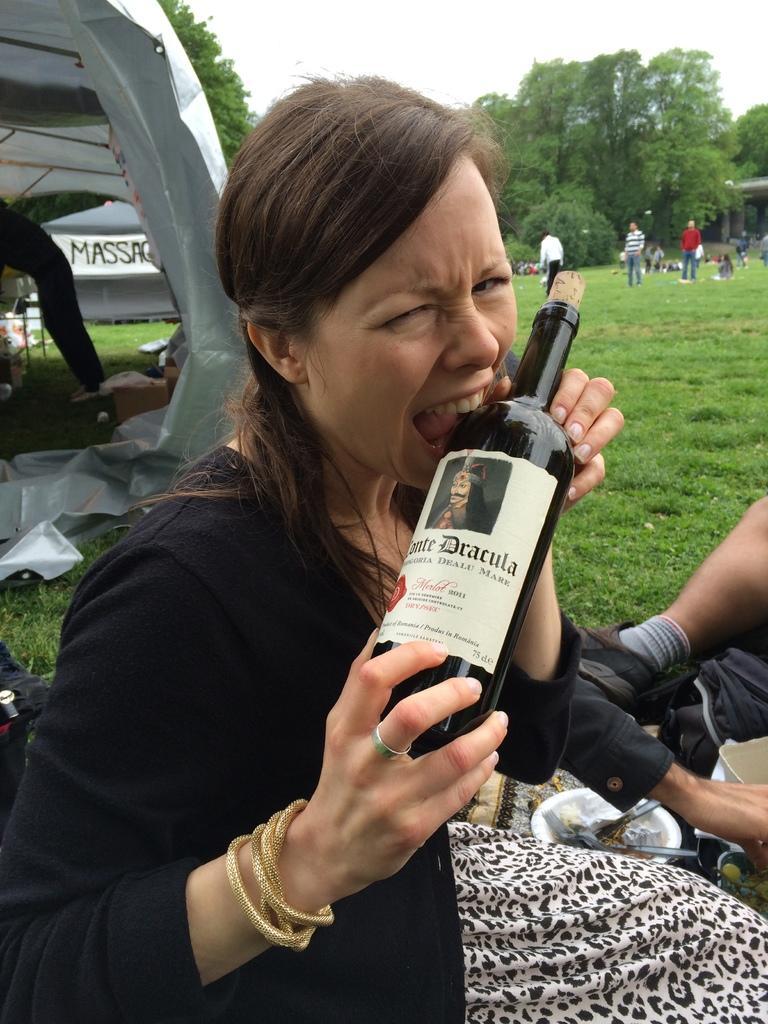How would you summarize this image in a sentence or two? In this image, woman is holding a bottle. There is a sticker on it. On right side, we can see human leg, socks, shoe and cloth. Here there is a bowl, some item is placed on it. And here grass. And the background ,we can see few peoples are there, tree. And left side, we can see some vehicle and tree. 